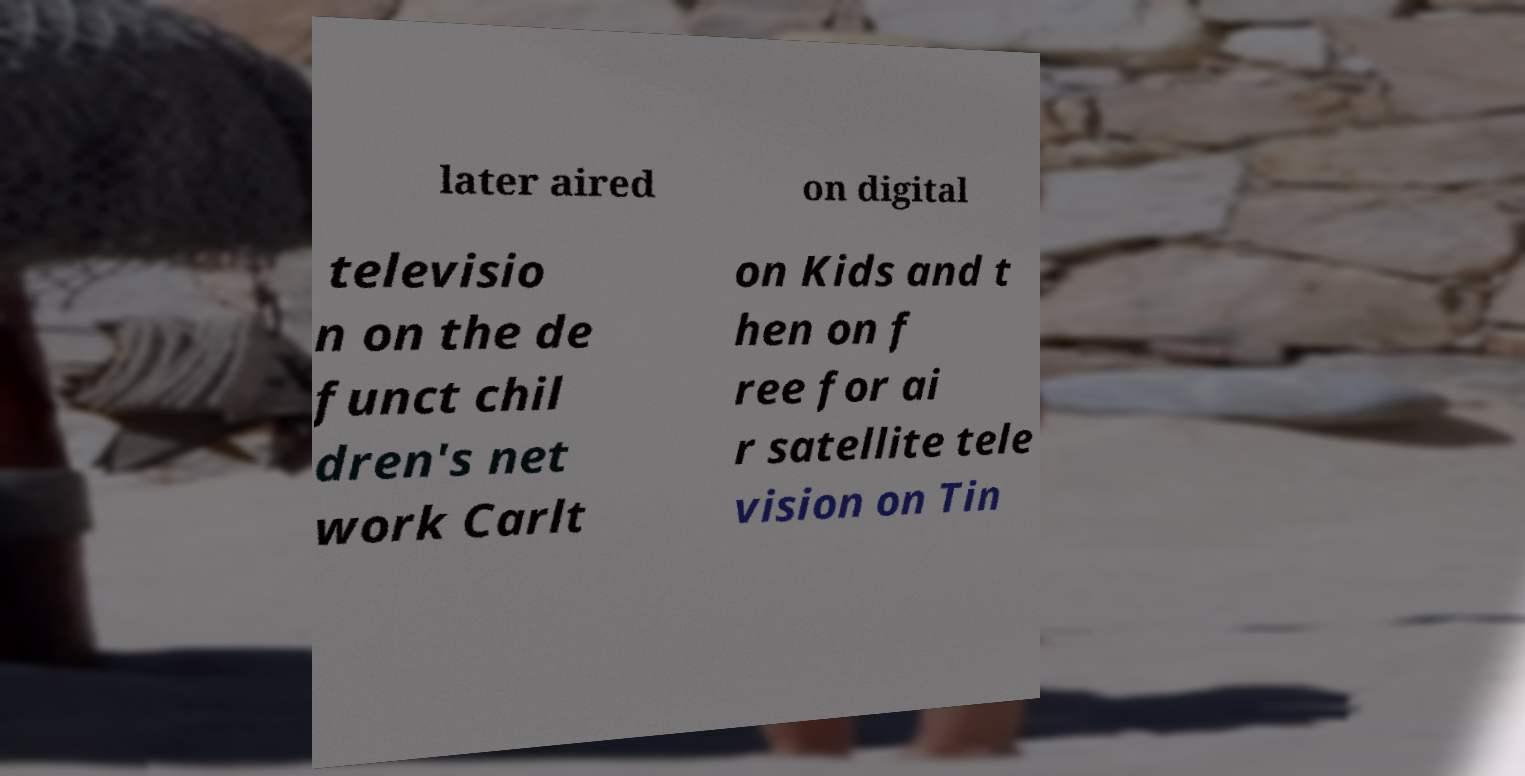There's text embedded in this image that I need extracted. Can you transcribe it verbatim? later aired on digital televisio n on the de funct chil dren's net work Carlt on Kids and t hen on f ree for ai r satellite tele vision on Tin 